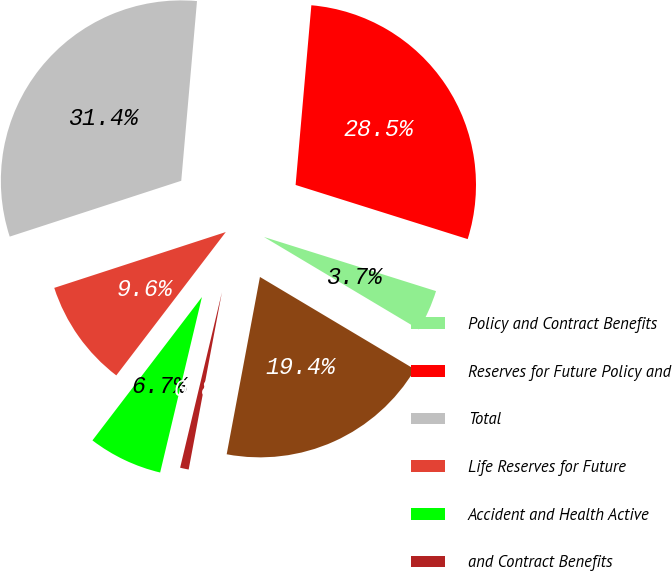<chart> <loc_0><loc_0><loc_500><loc_500><pie_chart><fcel>Policy and Contract Benefits<fcel>Reserves for Future Policy and<fcel>Total<fcel>Life Reserves for Future<fcel>Accident and Health Active<fcel>and Contract Benefits<fcel>Liability for Unpaid Claims<nl><fcel>3.71%<fcel>28.46%<fcel>31.4%<fcel>9.61%<fcel>6.66%<fcel>0.77%<fcel>19.39%<nl></chart> 